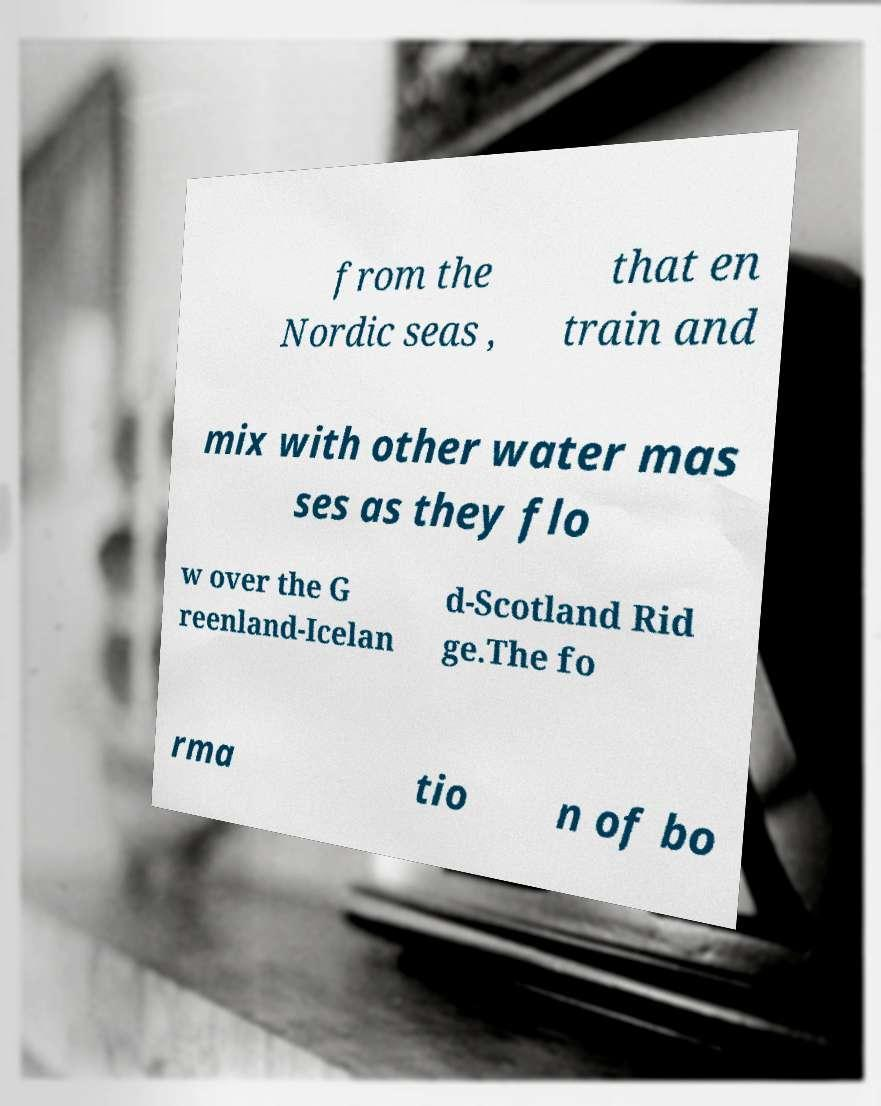Please read and relay the text visible in this image. What does it say? from the Nordic seas , that en train and mix with other water mas ses as they flo w over the G reenland-Icelan d-Scotland Rid ge.The fo rma tio n of bo 